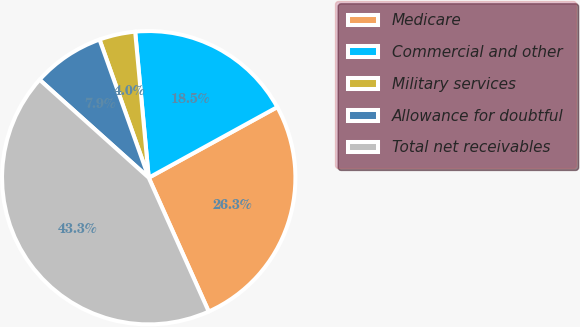<chart> <loc_0><loc_0><loc_500><loc_500><pie_chart><fcel>Medicare<fcel>Commercial and other<fcel>Military services<fcel>Allowance for doubtful<fcel>Total net receivables<nl><fcel>26.29%<fcel>18.48%<fcel>3.97%<fcel>7.91%<fcel>43.35%<nl></chart> 